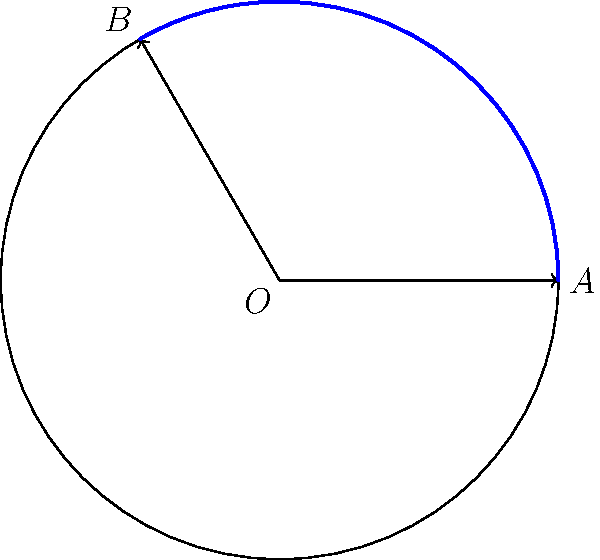In a circular sound dispersion pattern, the radius $r$ represents the maximum throw distance of a speaker, and the angle $\theta$ represents the coverage angle. If a speaker has a throw distance of 10 meters and a coverage angle of 120°, what is the area of the sector that represents the speaker's coverage? Round your answer to the nearest square meter. To solve this problem, we'll use the formula for the area of a sector:

$$A = \frac{1}{2}r^2\theta$$

Where:
$A$ is the area of the sector
$r$ is the radius (throw distance)
$\theta$ is the angle in radians

Steps:
1) We have $r = 10$ meters and $\theta = 120°$

2) Convert the angle to radians:
   $$\theta_{rad} = 120° \times \frac{\pi}{180°} = \frac{2\pi}{3} \approx 2.0944$$

3) Apply the formula:
   $$A = \frac{1}{2} \times 10^2 \times \frac{2\pi}{3}$$

4) Simplify:
   $$A = \frac{100\pi}{3} \approx 104.72$$

5) Round to the nearest square meter:
   $$A \approx 105 \text{ m}^2$$
Answer: 105 m² 